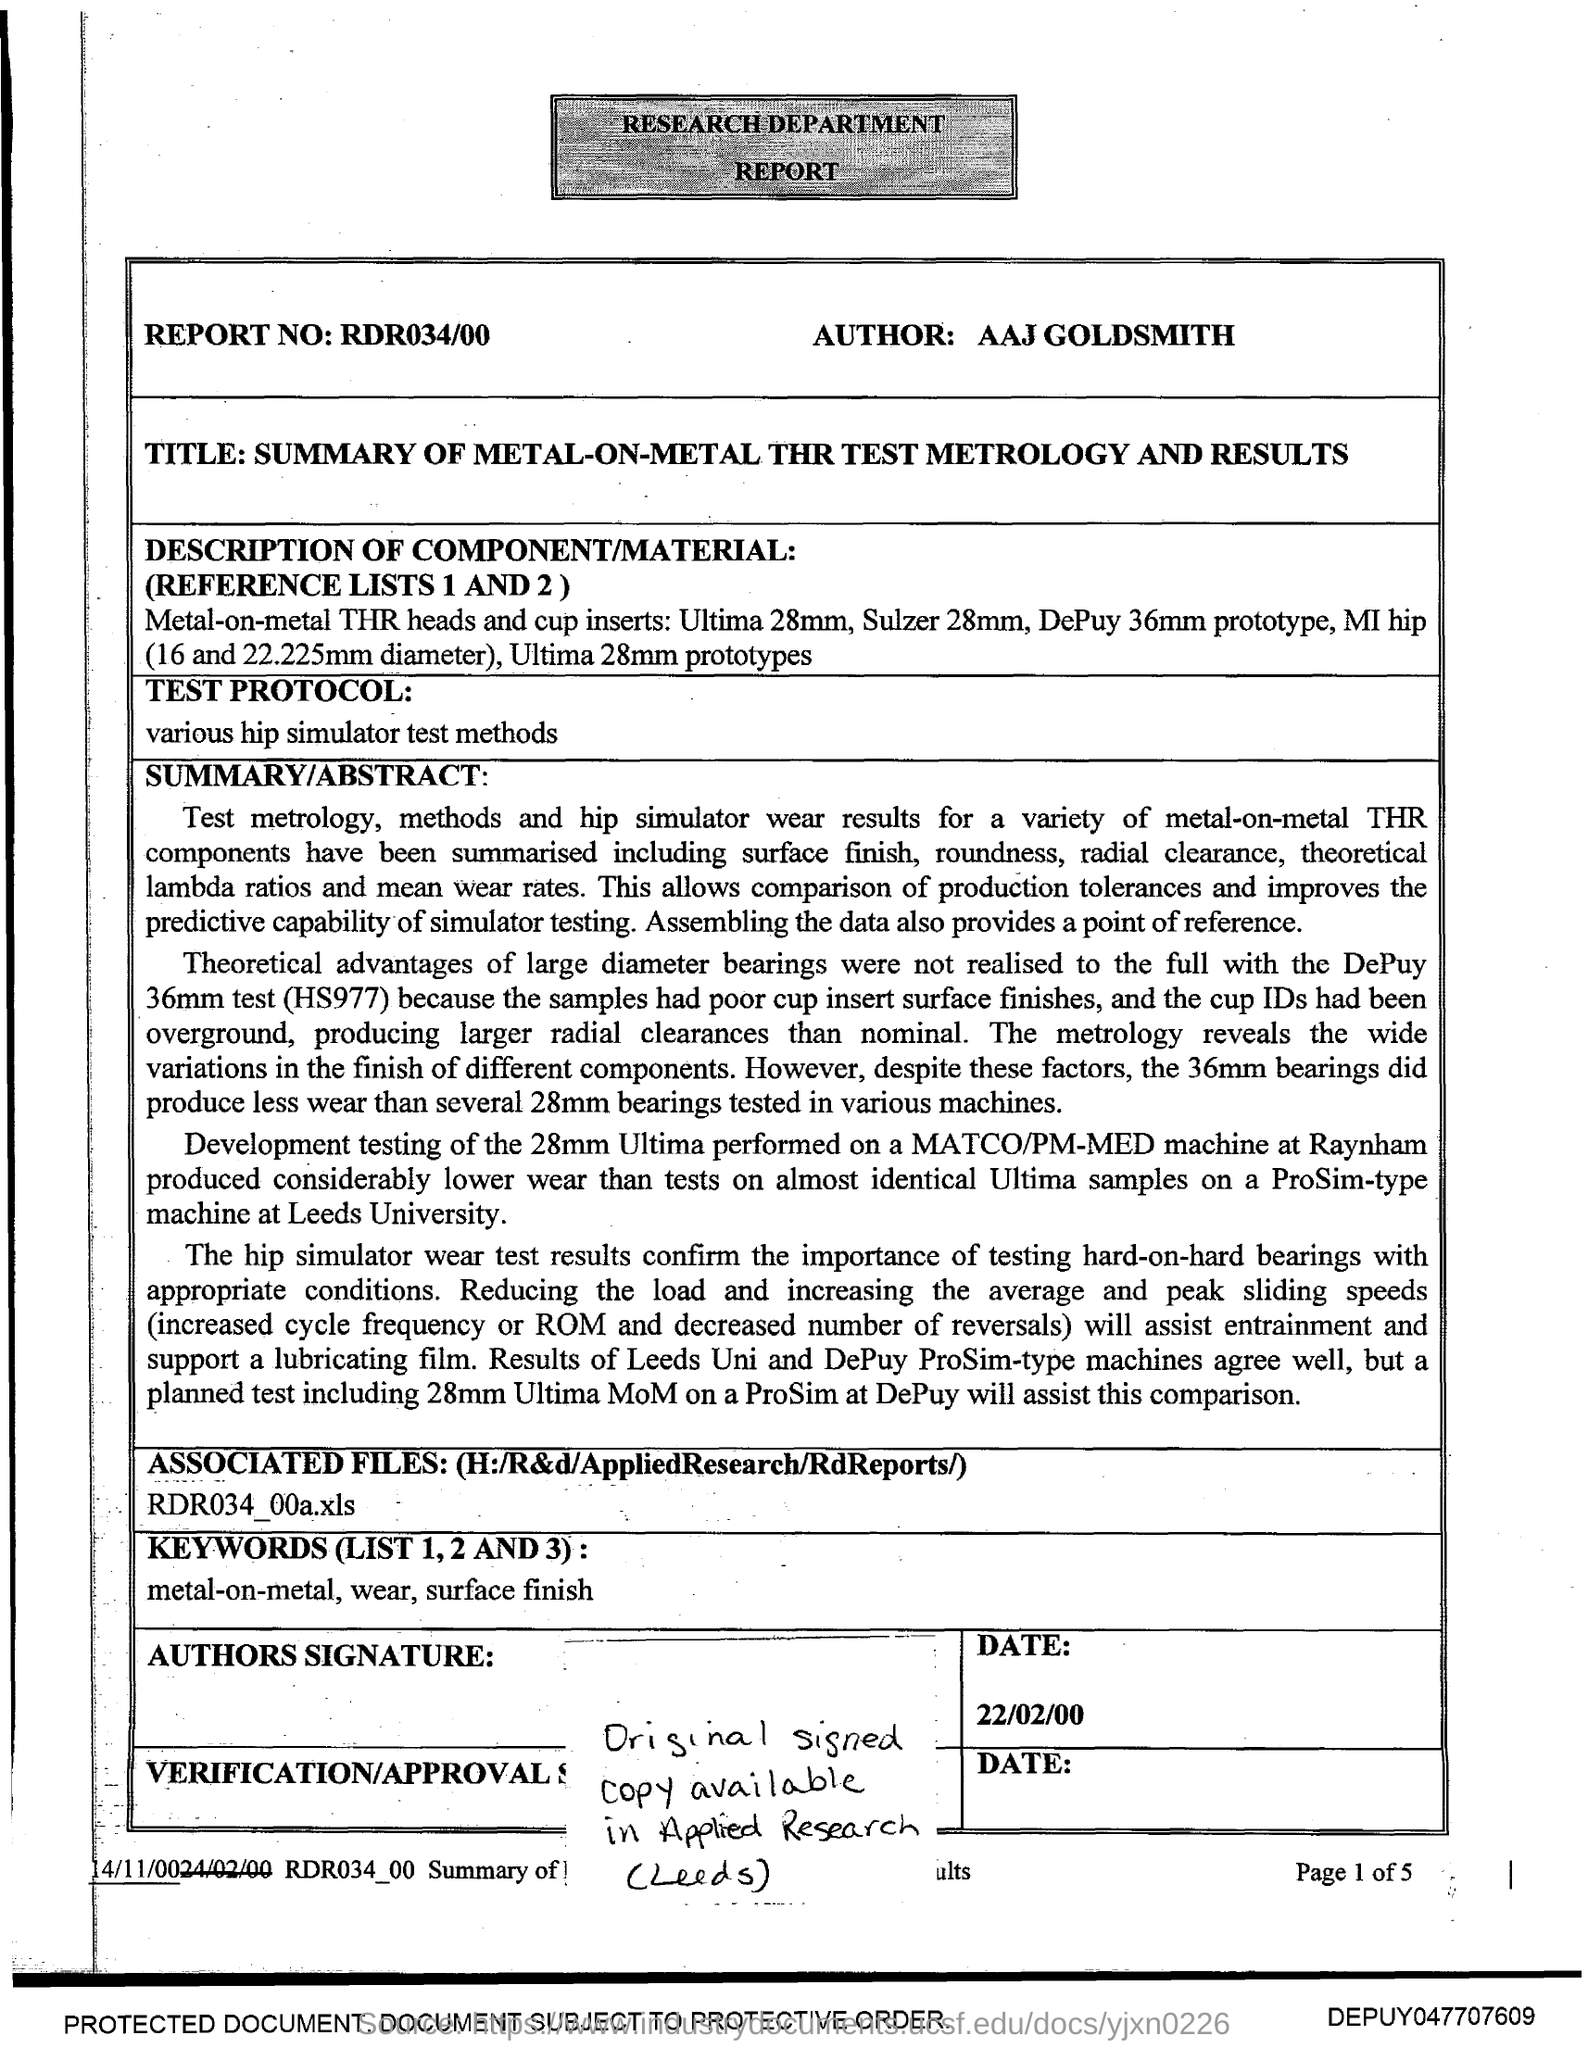Who is the Author?
Make the answer very short. AAJ GOLDSMITH. What is the Report number?
Your response must be concise. RDR034/00. 